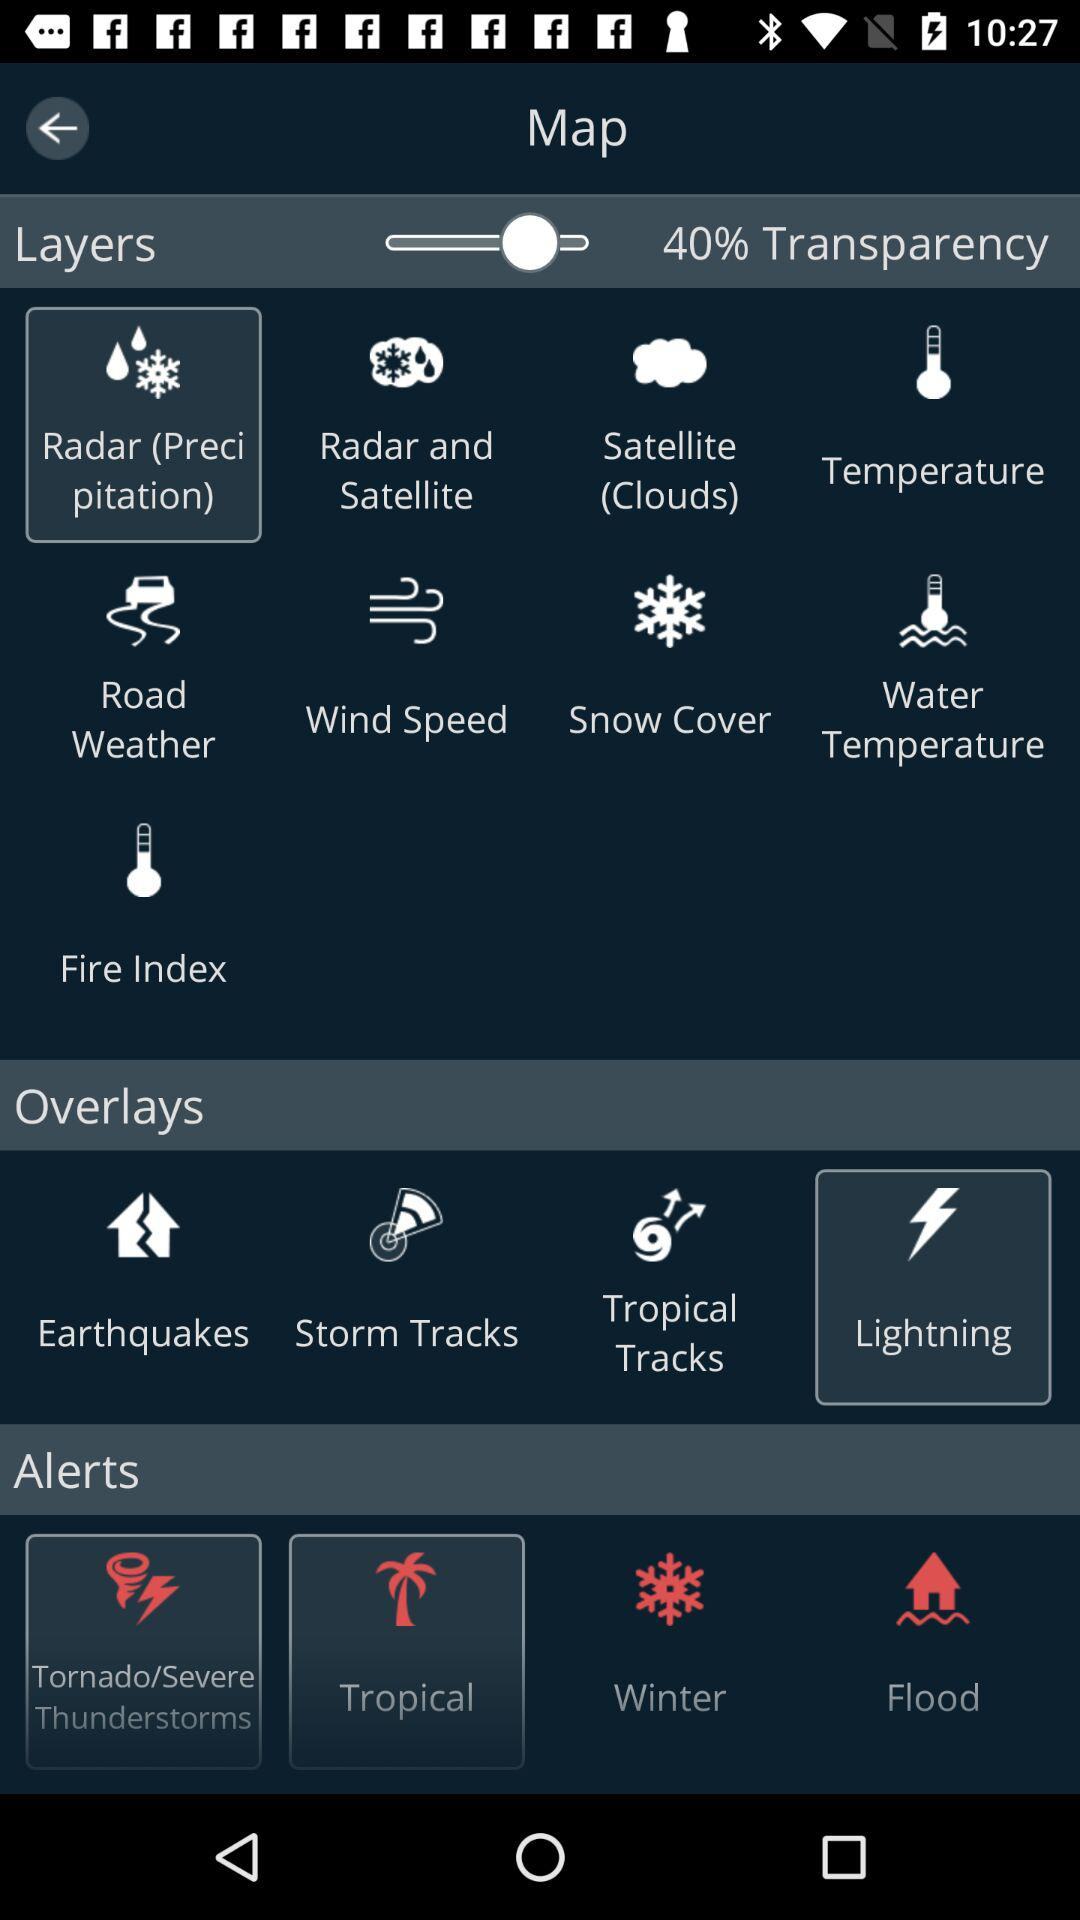Which option is selected in overlays? The selected option is "Lightning". 